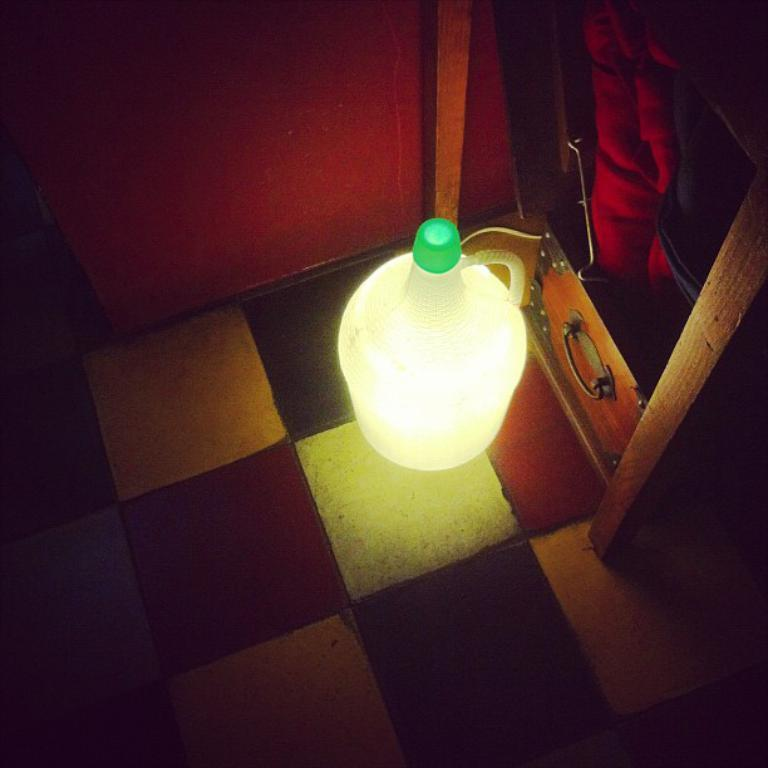What type of illumination is present in the image? There is light in the image. What surface can be seen beneath the objects in the image? There is a floor visible in the image. What material are the objects made of in the image? There are wooden objects in the image. What separates the space in the image? There is a wall in the image. What type of honey is being used to paint the wall in the image? There is no honey present in the image, and the wall is not being painted. 